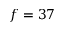Convert formula to latex. <formula><loc_0><loc_0><loc_500><loc_500>f = 3 7</formula> 